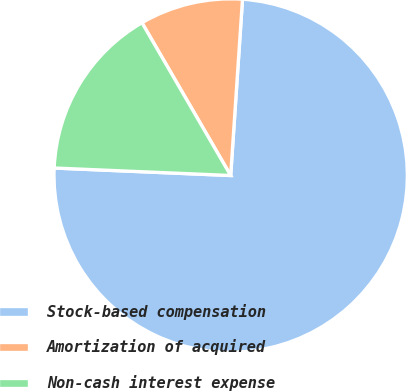Convert chart. <chart><loc_0><loc_0><loc_500><loc_500><pie_chart><fcel>Stock-based compensation<fcel>Amortization of acquired<fcel>Non-cash interest expense<nl><fcel>74.61%<fcel>9.44%<fcel>15.95%<nl></chart> 